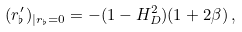<formula> <loc_0><loc_0><loc_500><loc_500>( r _ { \flat } ^ { \prime } ) _ { | r _ { \flat } = 0 } = - ( 1 - H _ { D } ^ { 2 } ) ( 1 + 2 \beta ) \, ,</formula> 